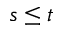<formula> <loc_0><loc_0><loc_500><loc_500>s \leq t</formula> 